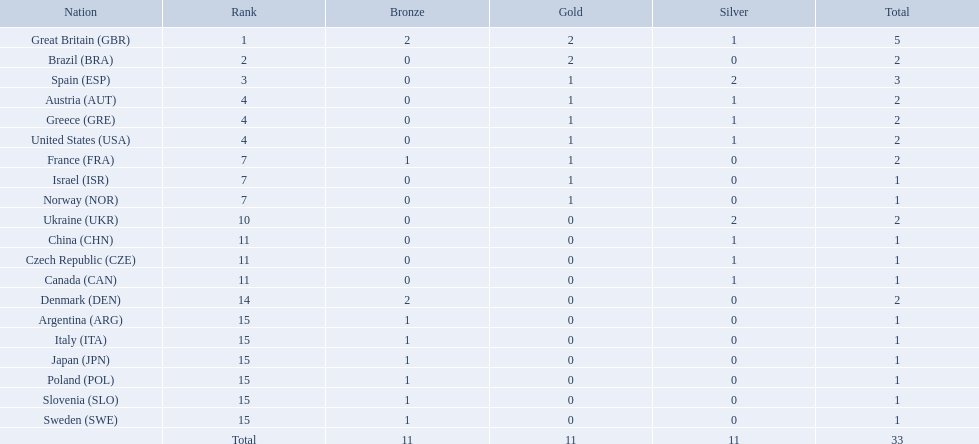How many medals did spain gain 3. Only country that got more medals? Spain (ESP). 